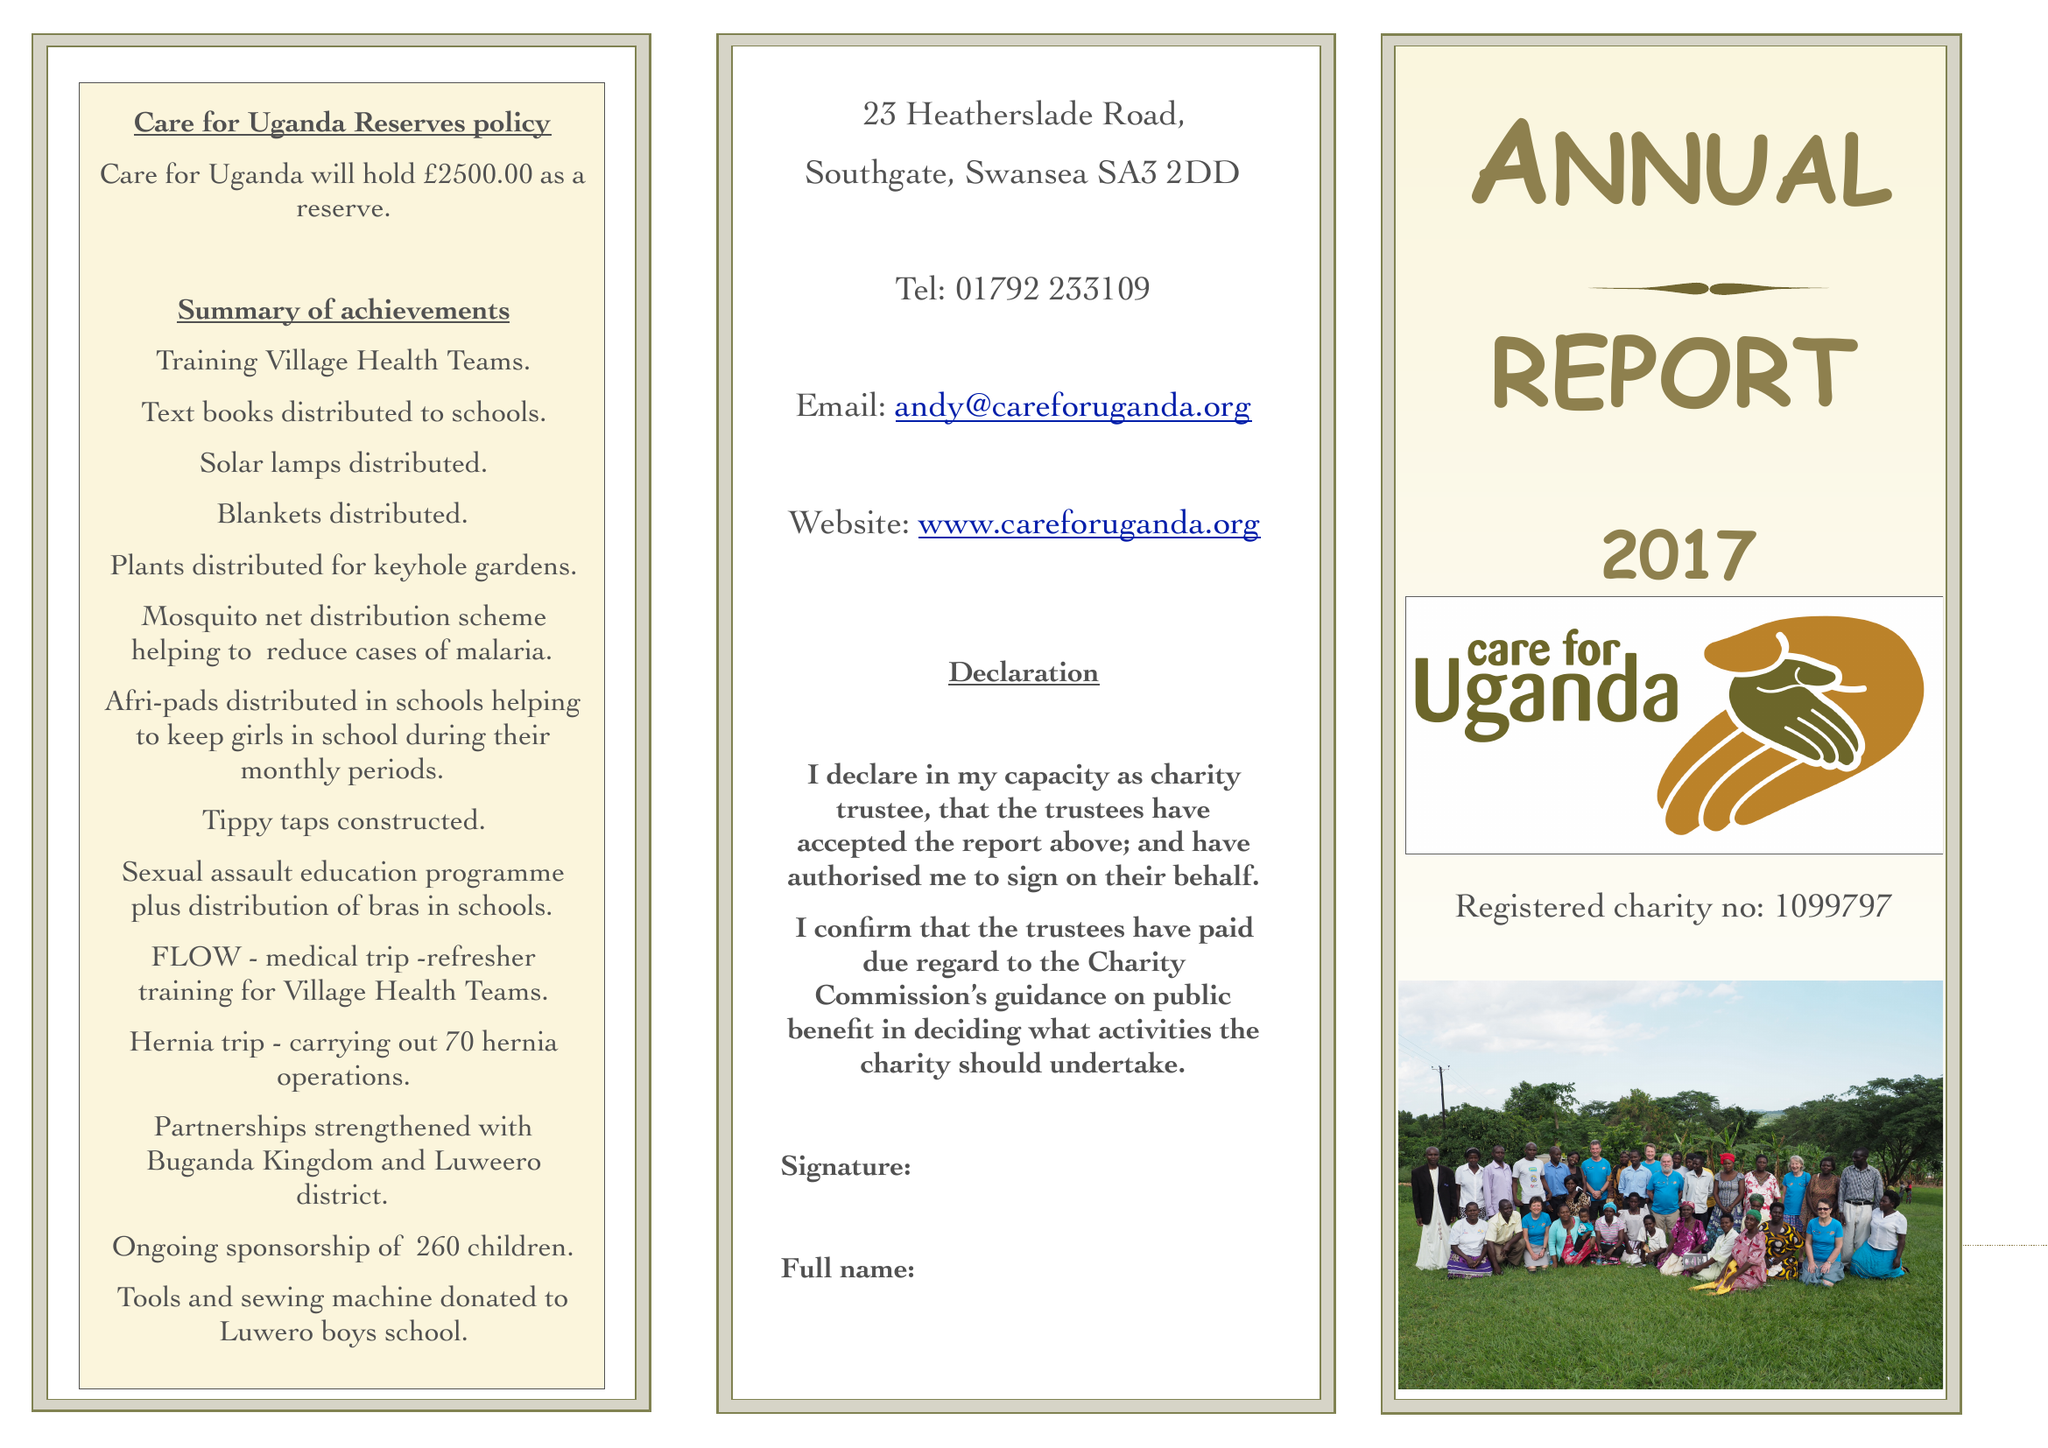What is the value for the address__post_town?
Answer the question using a single word or phrase. SWANSEA 